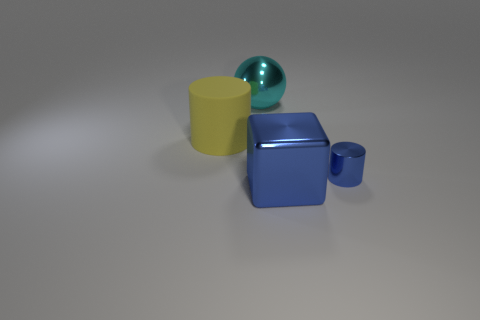Add 2 large gray matte cylinders. How many objects exist? 6 Subtract all cubes. How many objects are left? 3 Subtract 0 gray spheres. How many objects are left? 4 Subtract all big green rubber cylinders. Subtract all shiny balls. How many objects are left? 3 Add 4 cylinders. How many cylinders are left? 6 Add 4 blocks. How many blocks exist? 5 